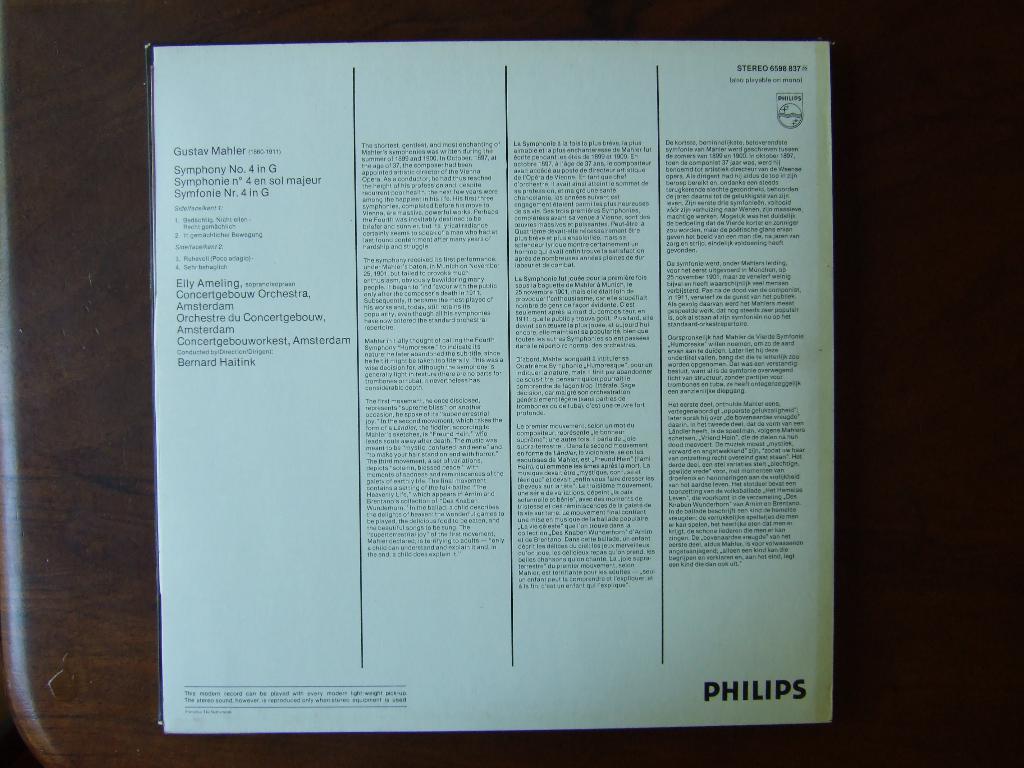What brand are these instructions for?
Ensure brevity in your answer.  Philips. 